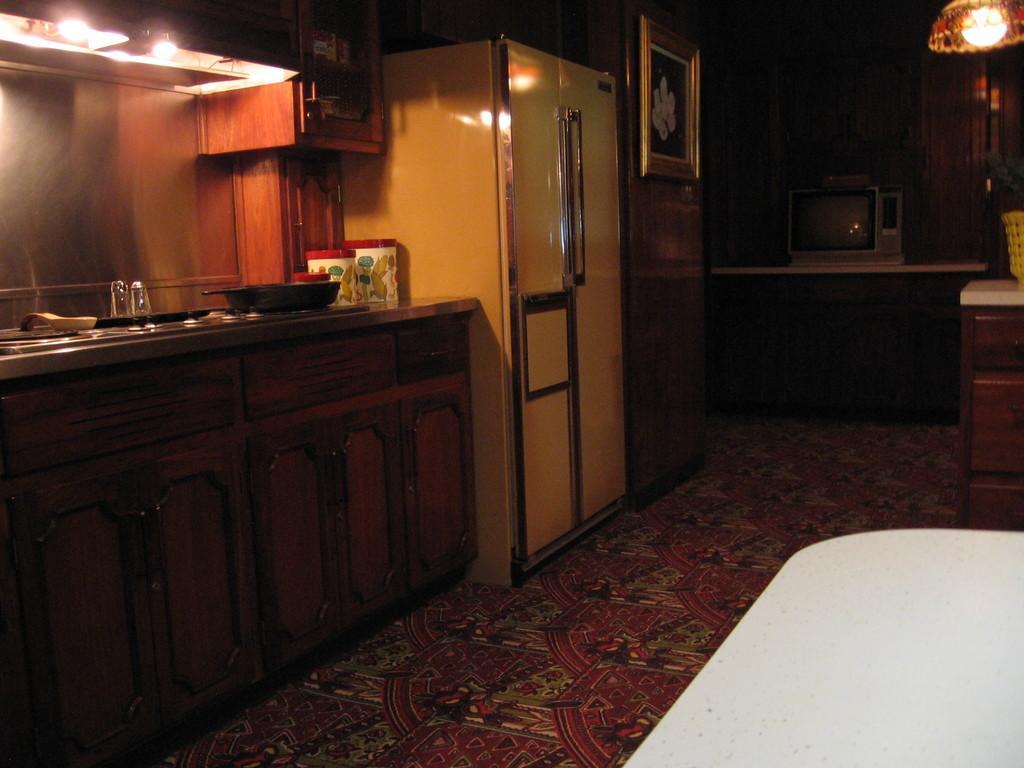Could you give a brief overview of what you see in this image? In this image I can see the pan on the stove. To the side I can see the glasses, boxes and some objects on the counter top. To the side I can see the cupboard and the frame to the wall. To the right I can see the table. In the background there is a television on the table. I can also see the white color surface to the right. And there are lights in the top. 